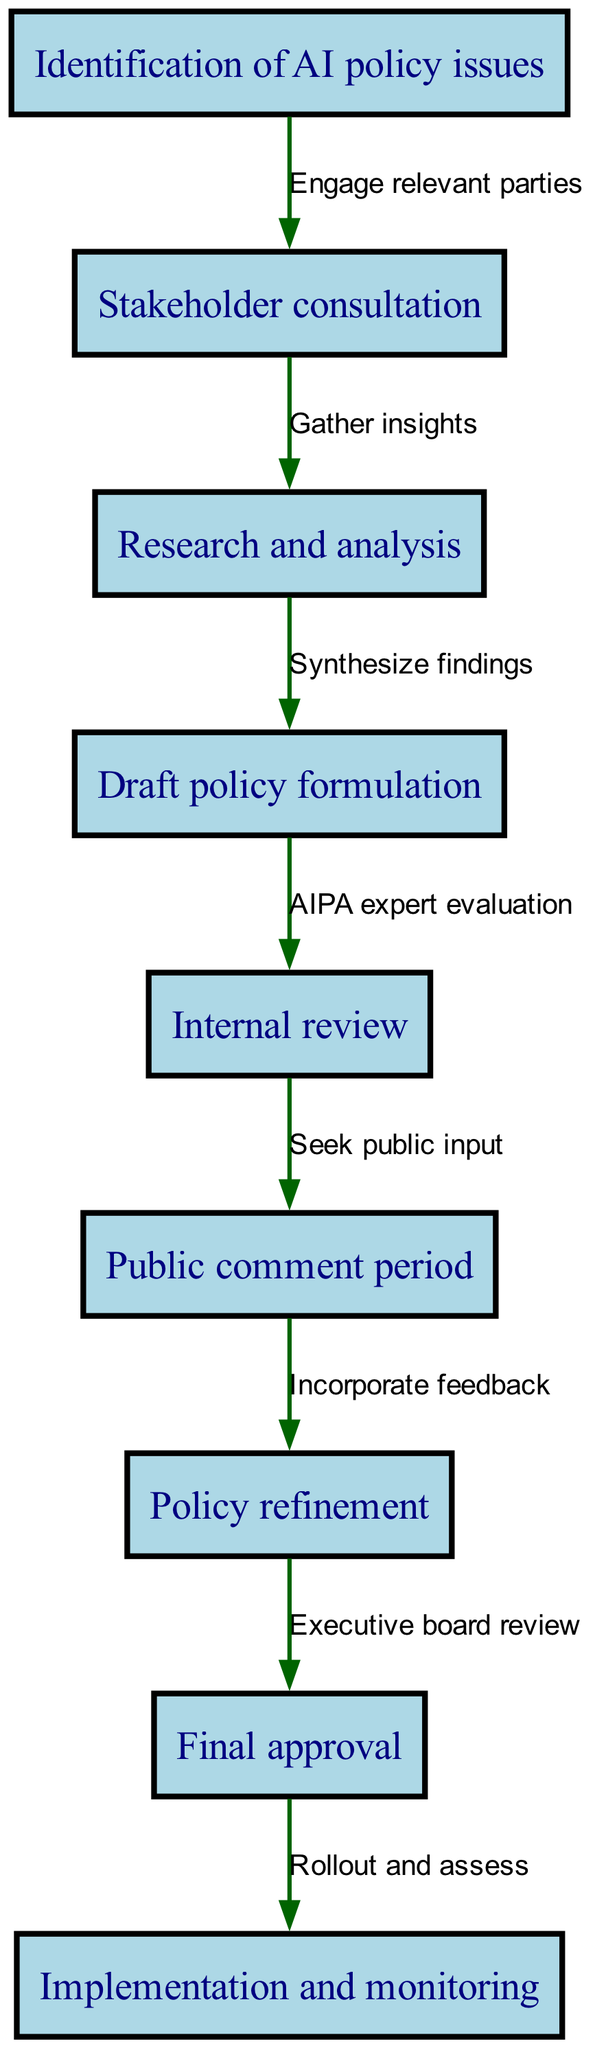What is the first stage of AIPA's AI policy development process? The first stage is indicated by node 1, which is labeled "Identification of AI policy issues."
Answer: Identification of AI policy issues How many nodes are in the flowchart? By counting the number of distinct stages represented as nodes, there are 9 nodes in total.
Answer: 9 What type of input is sought in the fifth stage? The fifth stage, labeled "Internal review," seeks "public input" as indicated by the edge connecting it to the sixth stage.
Answer: Public input What is the relationship between the third and fourth stages? The edge from the third stage ("Research and analysis") to the fourth stage ("Draft policy formulation") indicates the process of "Synthesize findings."
Answer: Synthesize findings During which stage does AIPA incorporate feedback? The stage where feedback is incorporated is indicated by node 7, labeled "Policy refinement." This follows the public comment period.
Answer: Policy refinement What occurs after the "Final approval" stage? The edge connecting the eighth stage to the ninth indicates the process that occurs afterward is "Rollout and assess."
Answer: Rollout and assess Which stages involve consultation or review? The second stage ("Stakeholder consultation") and the fifth stage ("Internal review") both involve types of consultation or review as indicated in the diagram.
Answer: Stakeholder consultation and Internal review What is the last stage of AIPA's AI policy development process? The last stage, as seen in node 9, is labeled "Implementation and monitoring."
Answer: Implementation and monitoring Which two stages are directly connected to "Public comment period"? The sixth stage is "Public comment period," which is connected to the preceding stage "Internal review" and the following stage "Policy refinement."
Answer: Internal review and Policy refinement 